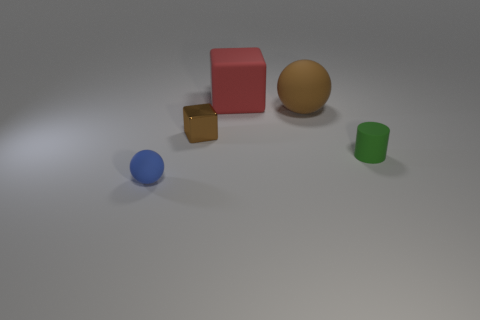Is there anything else that has the same material as the tiny brown block?
Your answer should be very brief. No. There is a small thing that is behind the matte cylinder; what material is it?
Your answer should be very brief. Metal. Is there any other thing that is the same color as the matte block?
Provide a short and direct response. No. There is a red block that is made of the same material as the small blue object; what is its size?
Keep it short and to the point. Large. What number of tiny things are either red blocks or yellow metal cylinders?
Your response must be concise. 0. What is the size of the sphere on the right side of the sphere that is to the left of the brown thing that is on the right side of the brown block?
Your answer should be very brief. Large. What number of metallic cubes have the same size as the brown metallic object?
Provide a succinct answer. 0. How many things are either metallic blocks or objects that are behind the small cylinder?
Offer a terse response. 3. What shape is the red thing?
Ensure brevity in your answer.  Cube. Is the tiny metallic block the same color as the big rubber ball?
Make the answer very short. Yes. 